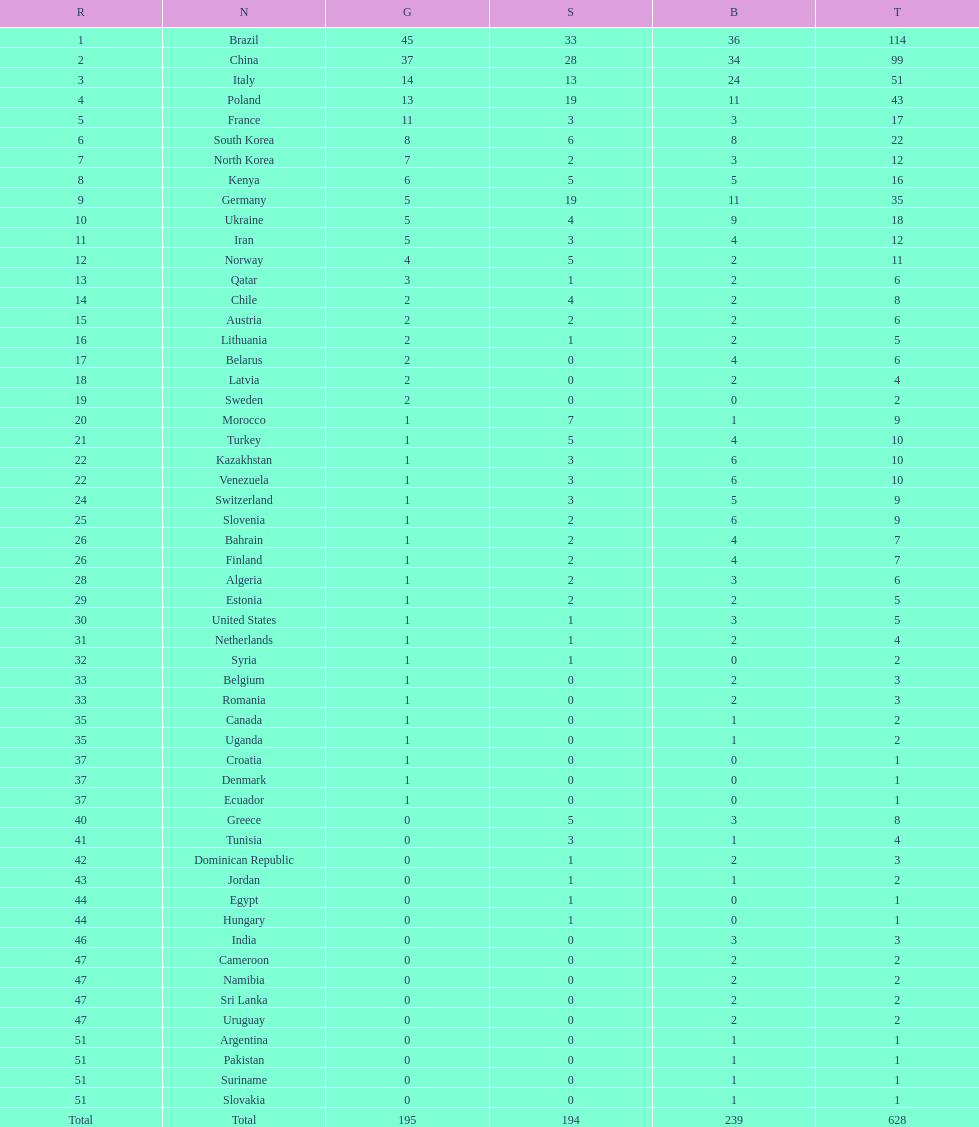Which nation earned the most gold medals? Brazil. 